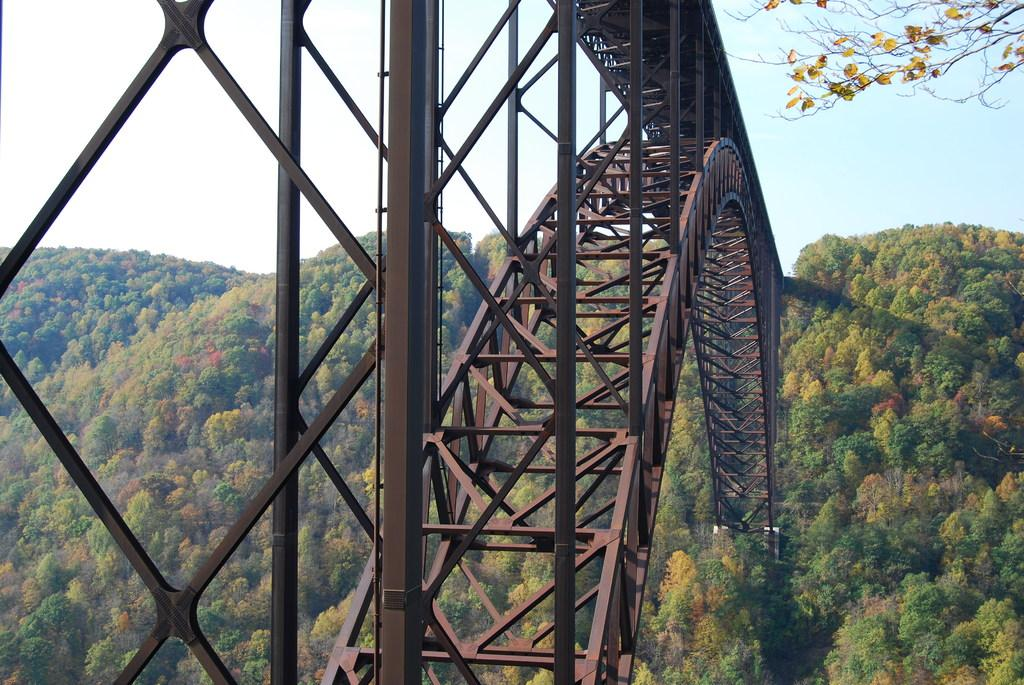What type of objects can be seen in the image? There are iron rods in the image. What natural elements are present in the image? There are trees in the image. What feature of the trees can be observed? Leaves are present on the tree stems. What is visible in the background of the image? The sky is clear and visible in the image. What type of boundary can be seen in the image? There is no boundary present in the image; it features iron rods, trees, and a clear sky. What thought is being expressed by the trees in the image? Trees do not express thoughts, as they are inanimate objects. 